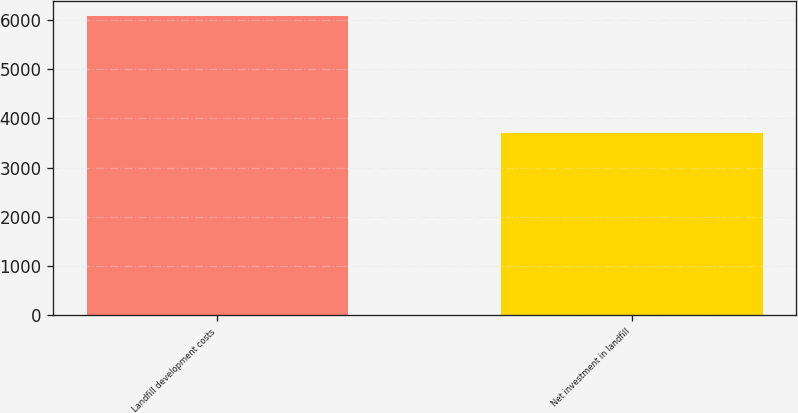Convert chart. <chart><loc_0><loc_0><loc_500><loc_500><bar_chart><fcel>Landfill development costs<fcel>Net investment in landfill<nl><fcel>6078.1<fcel>3712.3<nl></chart> 